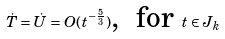<formula> <loc_0><loc_0><loc_500><loc_500>\dot { T } = \dot { U } = O ( t ^ { - \frac { 5 } { 3 } } ) \text {, \ for } t \in J _ { k }</formula> 